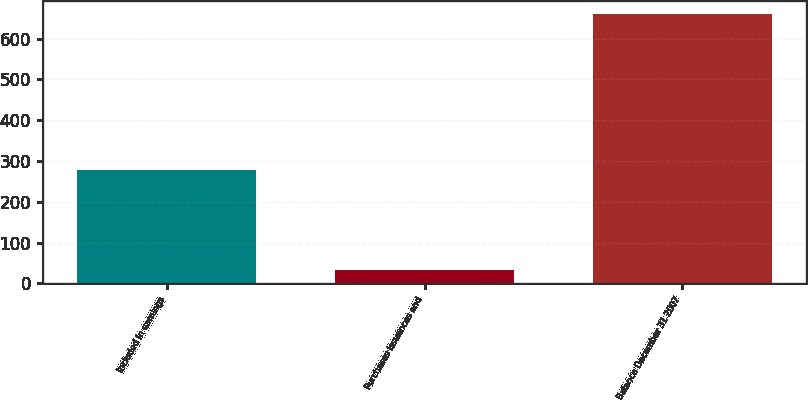Convert chart. <chart><loc_0><loc_0><loc_500><loc_500><bar_chart><fcel>Included in earnings<fcel>Purchases issuances and<fcel>Balance December 31 2007<nl><fcel>279<fcel>32<fcel>660<nl></chart> 